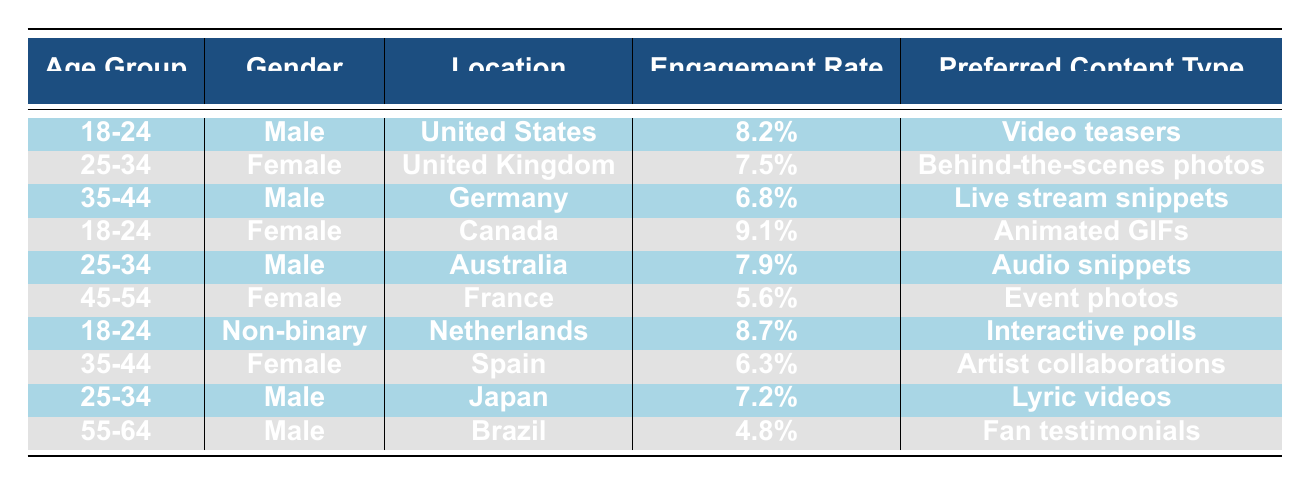What is the engagement rate of the 25-34 age group in the United Kingdom? The engagement rate for the 25-34 age group in the United Kingdom is listed in the corresponding row of the table, which shows it as 7.5%.
Answer: 7.5% Which age group has the highest engagement rate? By inspecting the engagement rates across all age groups, the highest engagement rate is found in the 18-24 age group for females in Canada, with a rate of 9.1%.
Answer: 18-24 (Female, Canada) Is the preferred content type for the 35-44 age group in Germany 'Live stream snippets'? Looking at the row for the 35-44 age group in Germany, the preferred content type is indeed 'Live stream snippets', confirming the statement to be true.
Answer: Yes How does the engagement rate of Non-binary individuals aged 18-24 compare to that of males in the same age group from the United States? The engagement rate for Non-binary individuals aged 18-24 from the Netherlands is 8.7%, and for males in the same age group from the United States, it is 8.2%. Non-binary individuals have a higher engagement rate by 0.5%.
Answer: Non-binary individuals have a higher engagement rate What is the average engagement rate across all age groups listed in the table? To calculate the average, add the engagement rates: 8.2% + 7.5% + 6.8% + 9.1% + 7.9% + 5.6% + 8.7% + 6.3% + 7.2% + 4.8% = 68.1%. There are 10 data points, so the average is 68.1% / 10 = 6.81%.
Answer: 6.81% Do any females aged 35-44 have a higher engagement rate than the average engagement rate calculated? The engagement rate for females aged 35-44 in Spain is 6.3%, which is lower than the calculated average engagement rate of 6.81%. Thus, the answer is no.
Answer: No 